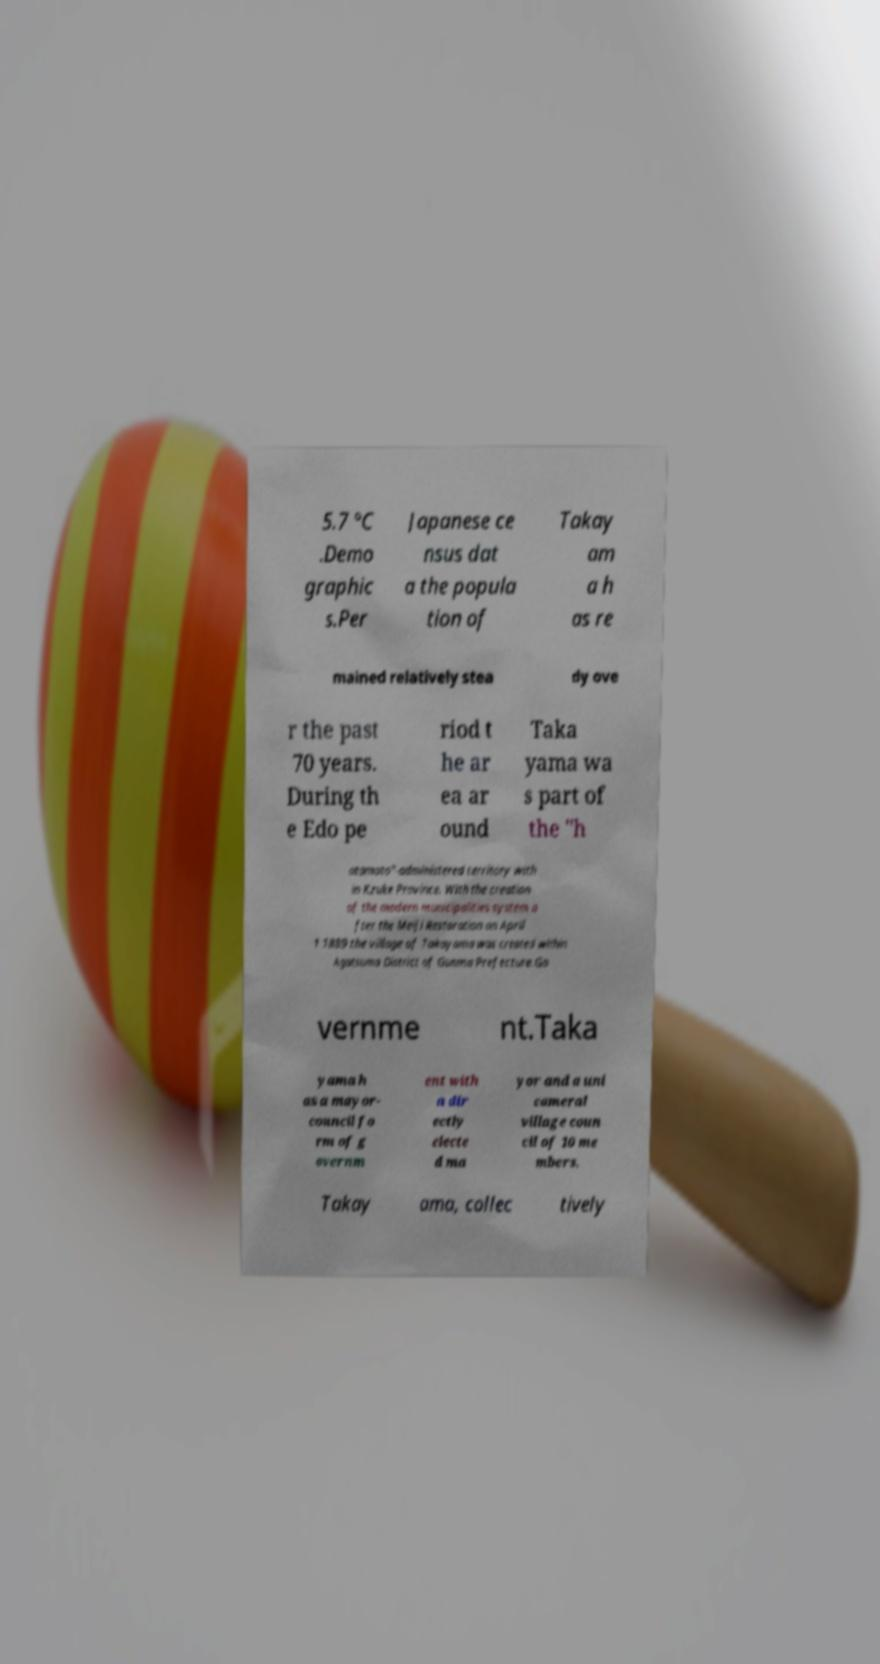There's text embedded in this image that I need extracted. Can you transcribe it verbatim? 5.7 °C .Demo graphic s.Per Japanese ce nsus dat a the popula tion of Takay am a h as re mained relatively stea dy ove r the past 70 years. During th e Edo pe riod t he ar ea ar ound Taka yama wa s part of the "h atamoto"-administered territory with in Kzuke Province. With the creation of the modern municipalities system a fter the Meiji Restoration on April 1 1889 the village of Takayama was created within Agatsuma District of Gunma Prefecture.Go vernme nt.Taka yama h as a mayor- council fo rm of g overnm ent with a dir ectly electe d ma yor and a uni cameral village coun cil of 10 me mbers. Takay ama, collec tively 